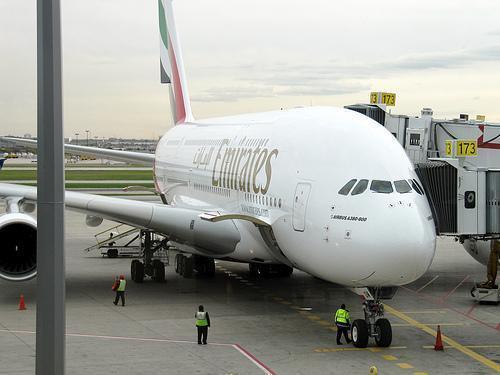How many cones are on the ground?
Give a very brief answer. 2. 